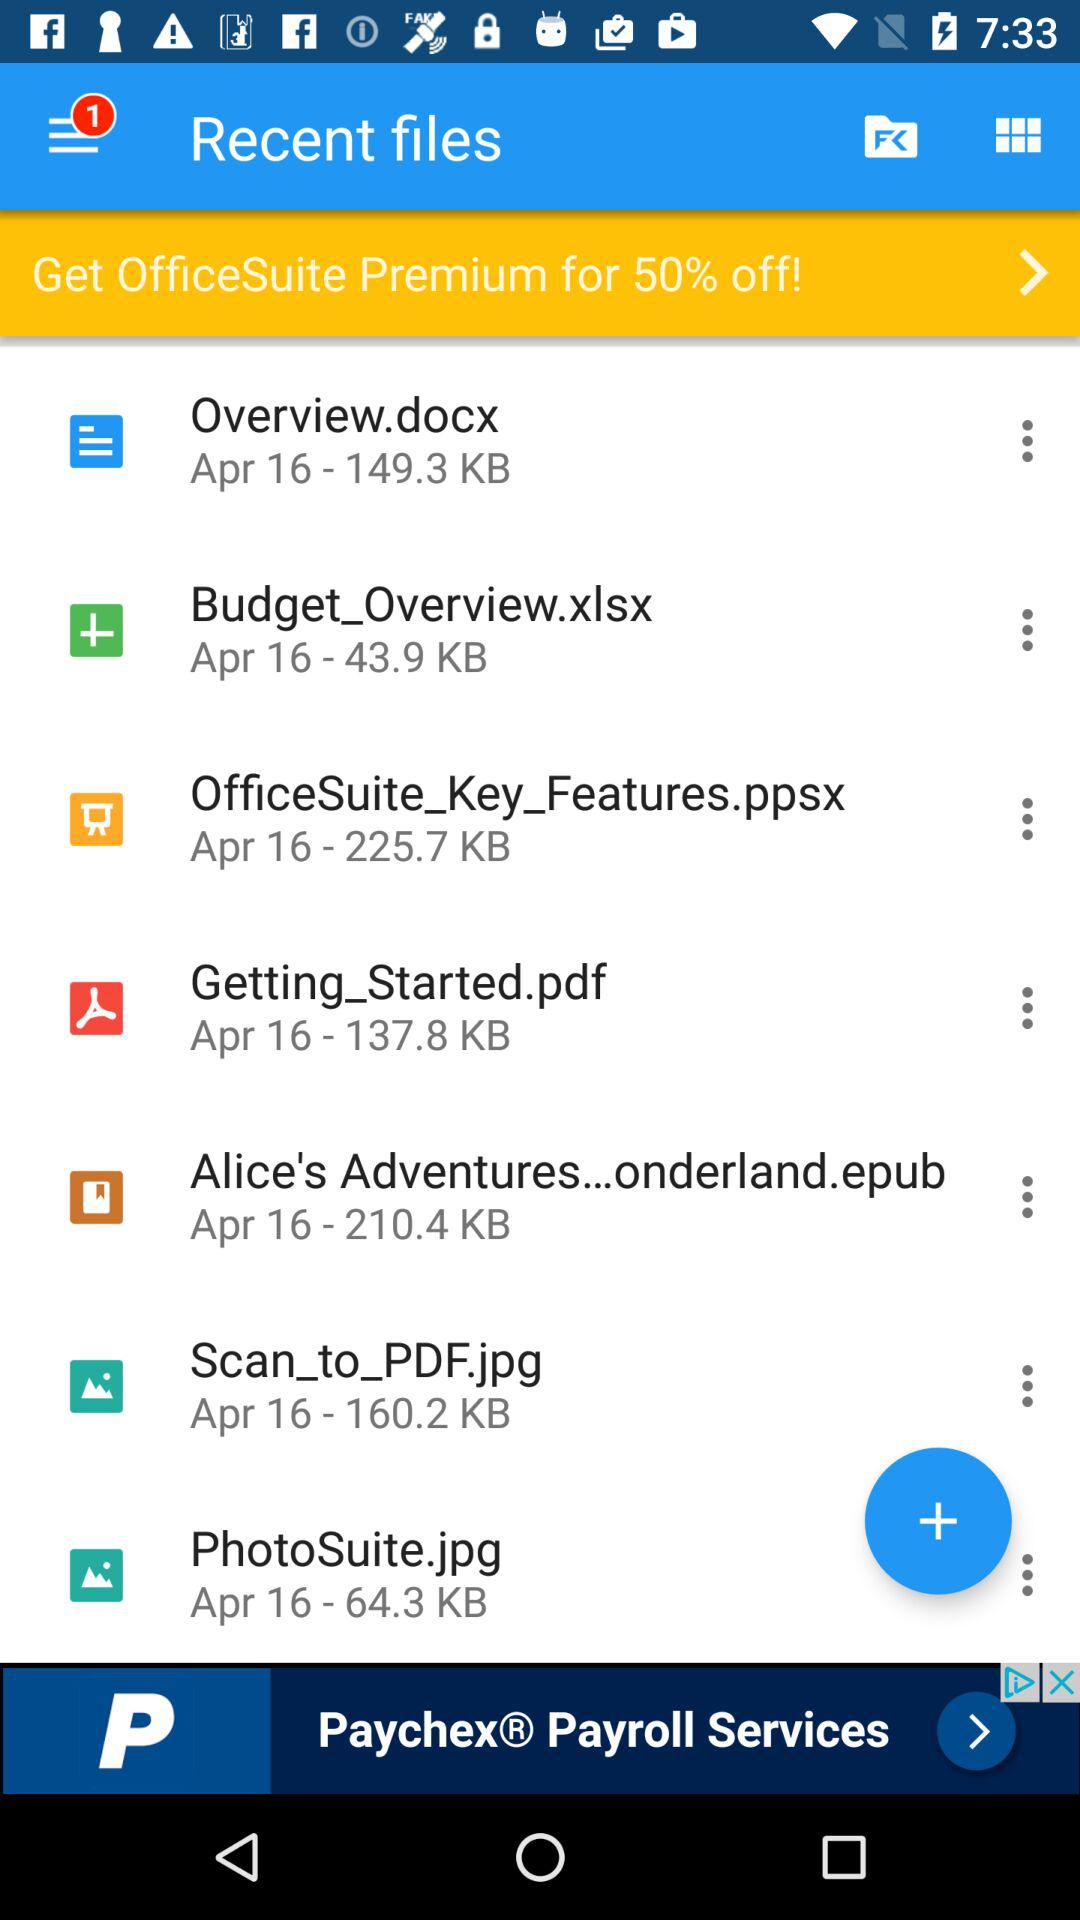How many new notifications are there? There is 1 new notification. 